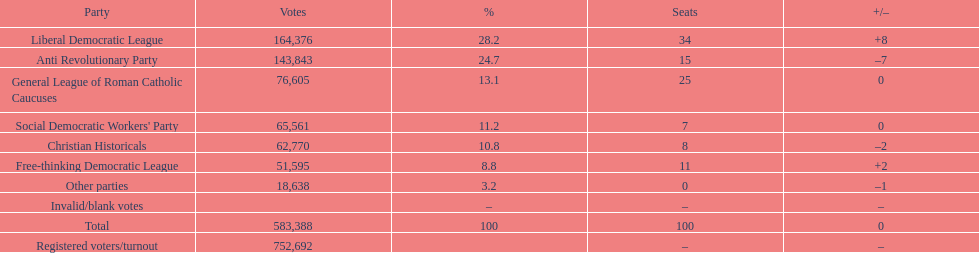By how many votes did the liberal democratic league surpass the free-thinking democratic league? 112,781. 